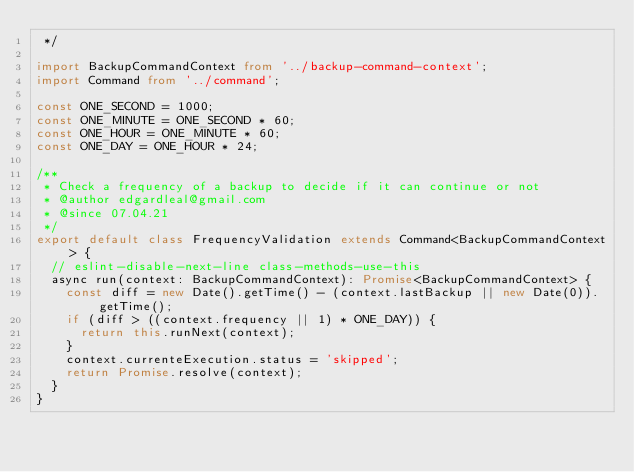Convert code to text. <code><loc_0><loc_0><loc_500><loc_500><_TypeScript_> */

import BackupCommandContext from '../backup-command-context';
import Command from '../command';

const ONE_SECOND = 1000;
const ONE_MINUTE = ONE_SECOND * 60;
const ONE_HOUR = ONE_MINUTE * 60;
const ONE_DAY = ONE_HOUR * 24;

/**
 * Check a frequency of a backup to decide if it can continue or not
 * @author edgardleal@gmail.com
 * @since 07.04.21
 */
export default class FrequencyValidation extends Command<BackupCommandContext> {
  // eslint-disable-next-line class-methods-use-this
  async run(context: BackupCommandContext): Promise<BackupCommandContext> {
    const diff = new Date().getTime() - (context.lastBackup || new Date(0)).getTime();
    if (diff > ((context.frequency || 1) * ONE_DAY)) {
      return this.runNext(context);
    }
    context.currenteExecution.status = 'skipped';
    return Promise.resolve(context);
  }
}
</code> 